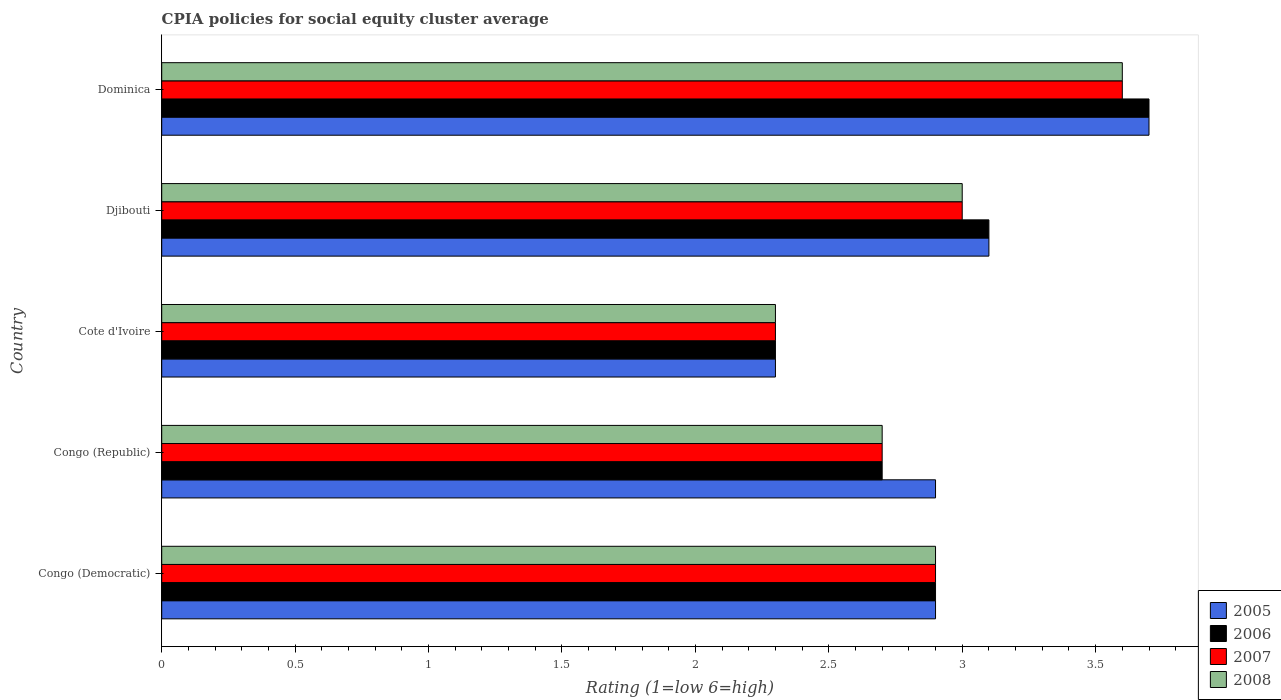How many different coloured bars are there?
Make the answer very short. 4. How many groups of bars are there?
Make the answer very short. 5. What is the label of the 5th group of bars from the top?
Give a very brief answer. Congo (Democratic). In how many cases, is the number of bars for a given country not equal to the number of legend labels?
Offer a very short reply. 0. Across all countries, what is the maximum CPIA rating in 2008?
Make the answer very short. 3.6. In which country was the CPIA rating in 2005 maximum?
Your response must be concise. Dominica. In which country was the CPIA rating in 2008 minimum?
Your answer should be compact. Cote d'Ivoire. What is the total CPIA rating in 2007 in the graph?
Ensure brevity in your answer.  14.5. What is the difference between the CPIA rating in 2005 in Congo (Democratic) and that in Cote d'Ivoire?
Your answer should be compact. 0.6. What is the difference between the CPIA rating in 2007 in Congo (Democratic) and the CPIA rating in 2005 in Cote d'Ivoire?
Ensure brevity in your answer.  0.6. What is the average CPIA rating in 2006 per country?
Make the answer very short. 2.94. What is the difference between the CPIA rating in 2008 and CPIA rating in 2007 in Dominica?
Provide a short and direct response. 0. In how many countries, is the CPIA rating in 2005 greater than 3.4 ?
Provide a short and direct response. 1. What is the ratio of the CPIA rating in 2006 in Congo (Democratic) to that in Congo (Republic)?
Offer a very short reply. 1.07. Is the CPIA rating in 2006 in Congo (Democratic) less than that in Congo (Republic)?
Provide a short and direct response. No. What is the difference between the highest and the second highest CPIA rating in 2007?
Your answer should be very brief. 0.6. What is the difference between the highest and the lowest CPIA rating in 2007?
Keep it short and to the point. 1.3. How many countries are there in the graph?
Give a very brief answer. 5. Are the values on the major ticks of X-axis written in scientific E-notation?
Keep it short and to the point. No. Does the graph contain grids?
Your response must be concise. No. How many legend labels are there?
Make the answer very short. 4. How are the legend labels stacked?
Provide a short and direct response. Vertical. What is the title of the graph?
Offer a very short reply. CPIA policies for social equity cluster average. What is the label or title of the Y-axis?
Provide a short and direct response. Country. What is the Rating (1=low 6=high) in 2006 in Congo (Democratic)?
Ensure brevity in your answer.  2.9. What is the Rating (1=low 6=high) in 2007 in Congo (Democratic)?
Provide a short and direct response. 2.9. What is the Rating (1=low 6=high) in 2008 in Congo (Democratic)?
Give a very brief answer. 2.9. What is the Rating (1=low 6=high) of 2007 in Congo (Republic)?
Give a very brief answer. 2.7. What is the Rating (1=low 6=high) of 2005 in Cote d'Ivoire?
Offer a very short reply. 2.3. What is the Rating (1=low 6=high) in 2005 in Djibouti?
Your answer should be very brief. 3.1. What is the Rating (1=low 6=high) in 2006 in Djibouti?
Give a very brief answer. 3.1. What is the Rating (1=low 6=high) in 2006 in Dominica?
Provide a succinct answer. 3.7. What is the Rating (1=low 6=high) of 2007 in Dominica?
Provide a short and direct response. 3.6. What is the Rating (1=low 6=high) of 2008 in Dominica?
Provide a short and direct response. 3.6. Across all countries, what is the maximum Rating (1=low 6=high) of 2005?
Make the answer very short. 3.7. Across all countries, what is the maximum Rating (1=low 6=high) in 2008?
Provide a short and direct response. 3.6. Across all countries, what is the minimum Rating (1=low 6=high) of 2006?
Make the answer very short. 2.3. Across all countries, what is the minimum Rating (1=low 6=high) of 2007?
Provide a short and direct response. 2.3. What is the total Rating (1=low 6=high) of 2007 in the graph?
Give a very brief answer. 14.5. What is the total Rating (1=low 6=high) in 2008 in the graph?
Keep it short and to the point. 14.5. What is the difference between the Rating (1=low 6=high) in 2005 in Congo (Democratic) and that in Congo (Republic)?
Provide a short and direct response. 0. What is the difference between the Rating (1=low 6=high) of 2006 in Congo (Democratic) and that in Congo (Republic)?
Ensure brevity in your answer.  0.2. What is the difference between the Rating (1=low 6=high) of 2008 in Congo (Democratic) and that in Congo (Republic)?
Provide a succinct answer. 0.2. What is the difference between the Rating (1=low 6=high) in 2007 in Congo (Democratic) and that in Cote d'Ivoire?
Your answer should be compact. 0.6. What is the difference between the Rating (1=low 6=high) of 2008 in Congo (Democratic) and that in Cote d'Ivoire?
Keep it short and to the point. 0.6. What is the difference between the Rating (1=low 6=high) of 2005 in Congo (Democratic) and that in Djibouti?
Give a very brief answer. -0.2. What is the difference between the Rating (1=low 6=high) in 2006 in Congo (Democratic) and that in Djibouti?
Ensure brevity in your answer.  -0.2. What is the difference between the Rating (1=low 6=high) of 2007 in Congo (Democratic) and that in Djibouti?
Ensure brevity in your answer.  -0.1. What is the difference between the Rating (1=low 6=high) of 2006 in Congo (Democratic) and that in Dominica?
Ensure brevity in your answer.  -0.8. What is the difference between the Rating (1=low 6=high) in 2007 in Congo (Democratic) and that in Dominica?
Offer a very short reply. -0.7. What is the difference between the Rating (1=low 6=high) of 2006 in Congo (Republic) and that in Cote d'Ivoire?
Keep it short and to the point. 0.4. What is the difference between the Rating (1=low 6=high) of 2007 in Congo (Republic) and that in Cote d'Ivoire?
Give a very brief answer. 0.4. What is the difference between the Rating (1=low 6=high) in 2005 in Congo (Republic) and that in Djibouti?
Your answer should be very brief. -0.2. What is the difference between the Rating (1=low 6=high) of 2006 in Congo (Republic) and that in Dominica?
Make the answer very short. -1. What is the difference between the Rating (1=low 6=high) of 2007 in Congo (Republic) and that in Dominica?
Keep it short and to the point. -0.9. What is the difference between the Rating (1=low 6=high) of 2008 in Congo (Republic) and that in Dominica?
Your answer should be compact. -0.9. What is the difference between the Rating (1=low 6=high) of 2007 in Cote d'Ivoire and that in Djibouti?
Keep it short and to the point. -0.7. What is the difference between the Rating (1=low 6=high) of 2008 in Cote d'Ivoire and that in Dominica?
Provide a succinct answer. -1.3. What is the difference between the Rating (1=low 6=high) in 2005 in Djibouti and that in Dominica?
Provide a succinct answer. -0.6. What is the difference between the Rating (1=low 6=high) of 2006 in Djibouti and that in Dominica?
Your answer should be compact. -0.6. What is the difference between the Rating (1=low 6=high) in 2007 in Djibouti and that in Dominica?
Provide a short and direct response. -0.6. What is the difference between the Rating (1=low 6=high) of 2008 in Djibouti and that in Dominica?
Give a very brief answer. -0.6. What is the difference between the Rating (1=low 6=high) of 2005 in Congo (Democratic) and the Rating (1=low 6=high) of 2006 in Congo (Republic)?
Offer a very short reply. 0.2. What is the difference between the Rating (1=low 6=high) of 2007 in Congo (Democratic) and the Rating (1=low 6=high) of 2008 in Congo (Republic)?
Provide a short and direct response. 0.2. What is the difference between the Rating (1=low 6=high) of 2005 in Congo (Democratic) and the Rating (1=low 6=high) of 2007 in Cote d'Ivoire?
Ensure brevity in your answer.  0.6. What is the difference between the Rating (1=low 6=high) in 2005 in Congo (Democratic) and the Rating (1=low 6=high) in 2008 in Cote d'Ivoire?
Offer a very short reply. 0.6. What is the difference between the Rating (1=low 6=high) in 2006 in Congo (Democratic) and the Rating (1=low 6=high) in 2007 in Cote d'Ivoire?
Your answer should be compact. 0.6. What is the difference between the Rating (1=low 6=high) in 2006 in Congo (Democratic) and the Rating (1=low 6=high) in 2008 in Cote d'Ivoire?
Ensure brevity in your answer.  0.6. What is the difference between the Rating (1=low 6=high) of 2007 in Congo (Democratic) and the Rating (1=low 6=high) of 2008 in Cote d'Ivoire?
Give a very brief answer. 0.6. What is the difference between the Rating (1=low 6=high) in 2005 in Congo (Democratic) and the Rating (1=low 6=high) in 2006 in Djibouti?
Provide a succinct answer. -0.2. What is the difference between the Rating (1=low 6=high) in 2005 in Congo (Democratic) and the Rating (1=low 6=high) in 2007 in Djibouti?
Ensure brevity in your answer.  -0.1. What is the difference between the Rating (1=low 6=high) in 2007 in Congo (Democratic) and the Rating (1=low 6=high) in 2008 in Djibouti?
Your answer should be compact. -0.1. What is the difference between the Rating (1=low 6=high) of 2005 in Congo (Democratic) and the Rating (1=low 6=high) of 2007 in Dominica?
Make the answer very short. -0.7. What is the difference between the Rating (1=low 6=high) of 2006 in Congo (Democratic) and the Rating (1=low 6=high) of 2008 in Dominica?
Ensure brevity in your answer.  -0.7. What is the difference between the Rating (1=low 6=high) in 2007 in Congo (Democratic) and the Rating (1=low 6=high) in 2008 in Dominica?
Provide a succinct answer. -0.7. What is the difference between the Rating (1=low 6=high) in 2005 in Congo (Republic) and the Rating (1=low 6=high) in 2008 in Cote d'Ivoire?
Keep it short and to the point. 0.6. What is the difference between the Rating (1=low 6=high) in 2006 in Congo (Republic) and the Rating (1=low 6=high) in 2008 in Cote d'Ivoire?
Your response must be concise. 0.4. What is the difference between the Rating (1=low 6=high) of 2007 in Congo (Republic) and the Rating (1=low 6=high) of 2008 in Cote d'Ivoire?
Your response must be concise. 0.4. What is the difference between the Rating (1=low 6=high) in 2005 in Congo (Republic) and the Rating (1=low 6=high) in 2008 in Djibouti?
Your response must be concise. -0.1. What is the difference between the Rating (1=low 6=high) in 2006 in Congo (Republic) and the Rating (1=low 6=high) in 2008 in Djibouti?
Keep it short and to the point. -0.3. What is the difference between the Rating (1=low 6=high) in 2005 in Congo (Republic) and the Rating (1=low 6=high) in 2006 in Dominica?
Offer a terse response. -0.8. What is the difference between the Rating (1=low 6=high) in 2005 in Congo (Republic) and the Rating (1=low 6=high) in 2008 in Dominica?
Make the answer very short. -0.7. What is the difference between the Rating (1=low 6=high) in 2006 in Congo (Republic) and the Rating (1=low 6=high) in 2007 in Dominica?
Your answer should be compact. -0.9. What is the difference between the Rating (1=low 6=high) of 2006 in Congo (Republic) and the Rating (1=low 6=high) of 2008 in Dominica?
Offer a terse response. -0.9. What is the difference between the Rating (1=low 6=high) of 2005 in Cote d'Ivoire and the Rating (1=low 6=high) of 2006 in Djibouti?
Give a very brief answer. -0.8. What is the difference between the Rating (1=low 6=high) in 2005 in Cote d'Ivoire and the Rating (1=low 6=high) in 2008 in Djibouti?
Ensure brevity in your answer.  -0.7. What is the difference between the Rating (1=low 6=high) of 2006 in Cote d'Ivoire and the Rating (1=low 6=high) of 2007 in Djibouti?
Make the answer very short. -0.7. What is the difference between the Rating (1=low 6=high) of 2005 in Cote d'Ivoire and the Rating (1=low 6=high) of 2006 in Dominica?
Your answer should be very brief. -1.4. What is the difference between the Rating (1=low 6=high) in 2005 in Cote d'Ivoire and the Rating (1=low 6=high) in 2007 in Dominica?
Your response must be concise. -1.3. What is the difference between the Rating (1=low 6=high) in 2005 in Djibouti and the Rating (1=low 6=high) in 2007 in Dominica?
Offer a very short reply. -0.5. What is the difference between the Rating (1=low 6=high) in 2006 in Djibouti and the Rating (1=low 6=high) in 2007 in Dominica?
Provide a short and direct response. -0.5. What is the difference between the Rating (1=low 6=high) of 2006 in Djibouti and the Rating (1=low 6=high) of 2008 in Dominica?
Your answer should be compact. -0.5. What is the difference between the Rating (1=low 6=high) of 2007 in Djibouti and the Rating (1=low 6=high) of 2008 in Dominica?
Keep it short and to the point. -0.6. What is the average Rating (1=low 6=high) of 2005 per country?
Keep it short and to the point. 2.98. What is the average Rating (1=low 6=high) in 2006 per country?
Your response must be concise. 2.94. What is the average Rating (1=low 6=high) in 2008 per country?
Your response must be concise. 2.9. What is the difference between the Rating (1=low 6=high) of 2006 and Rating (1=low 6=high) of 2008 in Congo (Democratic)?
Provide a succinct answer. 0. What is the difference between the Rating (1=low 6=high) in 2007 and Rating (1=low 6=high) in 2008 in Congo (Democratic)?
Provide a short and direct response. 0. What is the difference between the Rating (1=low 6=high) of 2005 and Rating (1=low 6=high) of 2006 in Congo (Republic)?
Give a very brief answer. 0.2. What is the difference between the Rating (1=low 6=high) of 2005 and Rating (1=low 6=high) of 2007 in Congo (Republic)?
Offer a terse response. 0.2. What is the difference between the Rating (1=low 6=high) in 2005 and Rating (1=low 6=high) in 2008 in Congo (Republic)?
Your answer should be very brief. 0.2. What is the difference between the Rating (1=low 6=high) of 2006 and Rating (1=low 6=high) of 2007 in Congo (Republic)?
Give a very brief answer. 0. What is the difference between the Rating (1=low 6=high) of 2005 and Rating (1=low 6=high) of 2006 in Cote d'Ivoire?
Give a very brief answer. 0. What is the difference between the Rating (1=low 6=high) in 2006 and Rating (1=low 6=high) in 2007 in Cote d'Ivoire?
Provide a short and direct response. 0. What is the difference between the Rating (1=low 6=high) of 2006 and Rating (1=low 6=high) of 2008 in Cote d'Ivoire?
Offer a terse response. 0. What is the difference between the Rating (1=low 6=high) of 2007 and Rating (1=low 6=high) of 2008 in Cote d'Ivoire?
Provide a short and direct response. 0. What is the difference between the Rating (1=low 6=high) in 2005 and Rating (1=low 6=high) in 2006 in Djibouti?
Your answer should be very brief. 0. What is the difference between the Rating (1=low 6=high) in 2005 and Rating (1=low 6=high) in 2008 in Djibouti?
Keep it short and to the point. 0.1. What is the difference between the Rating (1=low 6=high) of 2006 and Rating (1=low 6=high) of 2007 in Dominica?
Ensure brevity in your answer.  0.1. What is the ratio of the Rating (1=low 6=high) of 2006 in Congo (Democratic) to that in Congo (Republic)?
Your answer should be very brief. 1.07. What is the ratio of the Rating (1=low 6=high) of 2007 in Congo (Democratic) to that in Congo (Republic)?
Your response must be concise. 1.07. What is the ratio of the Rating (1=low 6=high) in 2008 in Congo (Democratic) to that in Congo (Republic)?
Make the answer very short. 1.07. What is the ratio of the Rating (1=low 6=high) of 2005 in Congo (Democratic) to that in Cote d'Ivoire?
Offer a very short reply. 1.26. What is the ratio of the Rating (1=low 6=high) in 2006 in Congo (Democratic) to that in Cote d'Ivoire?
Offer a terse response. 1.26. What is the ratio of the Rating (1=low 6=high) in 2007 in Congo (Democratic) to that in Cote d'Ivoire?
Give a very brief answer. 1.26. What is the ratio of the Rating (1=low 6=high) of 2008 in Congo (Democratic) to that in Cote d'Ivoire?
Your response must be concise. 1.26. What is the ratio of the Rating (1=low 6=high) in 2005 in Congo (Democratic) to that in Djibouti?
Make the answer very short. 0.94. What is the ratio of the Rating (1=low 6=high) of 2006 in Congo (Democratic) to that in Djibouti?
Your response must be concise. 0.94. What is the ratio of the Rating (1=low 6=high) of 2007 in Congo (Democratic) to that in Djibouti?
Your response must be concise. 0.97. What is the ratio of the Rating (1=low 6=high) in 2008 in Congo (Democratic) to that in Djibouti?
Offer a terse response. 0.97. What is the ratio of the Rating (1=low 6=high) of 2005 in Congo (Democratic) to that in Dominica?
Give a very brief answer. 0.78. What is the ratio of the Rating (1=low 6=high) in 2006 in Congo (Democratic) to that in Dominica?
Keep it short and to the point. 0.78. What is the ratio of the Rating (1=low 6=high) in 2007 in Congo (Democratic) to that in Dominica?
Give a very brief answer. 0.81. What is the ratio of the Rating (1=low 6=high) of 2008 in Congo (Democratic) to that in Dominica?
Provide a succinct answer. 0.81. What is the ratio of the Rating (1=low 6=high) in 2005 in Congo (Republic) to that in Cote d'Ivoire?
Provide a succinct answer. 1.26. What is the ratio of the Rating (1=low 6=high) in 2006 in Congo (Republic) to that in Cote d'Ivoire?
Your response must be concise. 1.17. What is the ratio of the Rating (1=low 6=high) in 2007 in Congo (Republic) to that in Cote d'Ivoire?
Make the answer very short. 1.17. What is the ratio of the Rating (1=low 6=high) in 2008 in Congo (Republic) to that in Cote d'Ivoire?
Keep it short and to the point. 1.17. What is the ratio of the Rating (1=low 6=high) of 2005 in Congo (Republic) to that in Djibouti?
Offer a terse response. 0.94. What is the ratio of the Rating (1=low 6=high) of 2006 in Congo (Republic) to that in Djibouti?
Provide a short and direct response. 0.87. What is the ratio of the Rating (1=low 6=high) of 2007 in Congo (Republic) to that in Djibouti?
Your answer should be compact. 0.9. What is the ratio of the Rating (1=low 6=high) in 2008 in Congo (Republic) to that in Djibouti?
Ensure brevity in your answer.  0.9. What is the ratio of the Rating (1=low 6=high) of 2005 in Congo (Republic) to that in Dominica?
Make the answer very short. 0.78. What is the ratio of the Rating (1=low 6=high) in 2006 in Congo (Republic) to that in Dominica?
Make the answer very short. 0.73. What is the ratio of the Rating (1=low 6=high) of 2005 in Cote d'Ivoire to that in Djibouti?
Your answer should be compact. 0.74. What is the ratio of the Rating (1=low 6=high) of 2006 in Cote d'Ivoire to that in Djibouti?
Keep it short and to the point. 0.74. What is the ratio of the Rating (1=low 6=high) in 2007 in Cote d'Ivoire to that in Djibouti?
Provide a short and direct response. 0.77. What is the ratio of the Rating (1=low 6=high) in 2008 in Cote d'Ivoire to that in Djibouti?
Your response must be concise. 0.77. What is the ratio of the Rating (1=low 6=high) of 2005 in Cote d'Ivoire to that in Dominica?
Keep it short and to the point. 0.62. What is the ratio of the Rating (1=low 6=high) of 2006 in Cote d'Ivoire to that in Dominica?
Your response must be concise. 0.62. What is the ratio of the Rating (1=low 6=high) in 2007 in Cote d'Ivoire to that in Dominica?
Provide a short and direct response. 0.64. What is the ratio of the Rating (1=low 6=high) in 2008 in Cote d'Ivoire to that in Dominica?
Ensure brevity in your answer.  0.64. What is the ratio of the Rating (1=low 6=high) of 2005 in Djibouti to that in Dominica?
Keep it short and to the point. 0.84. What is the ratio of the Rating (1=low 6=high) of 2006 in Djibouti to that in Dominica?
Make the answer very short. 0.84. What is the ratio of the Rating (1=low 6=high) in 2007 in Djibouti to that in Dominica?
Keep it short and to the point. 0.83. What is the difference between the highest and the second highest Rating (1=low 6=high) of 2008?
Provide a short and direct response. 0.6. What is the difference between the highest and the lowest Rating (1=low 6=high) of 2005?
Provide a short and direct response. 1.4. What is the difference between the highest and the lowest Rating (1=low 6=high) of 2008?
Provide a succinct answer. 1.3. 